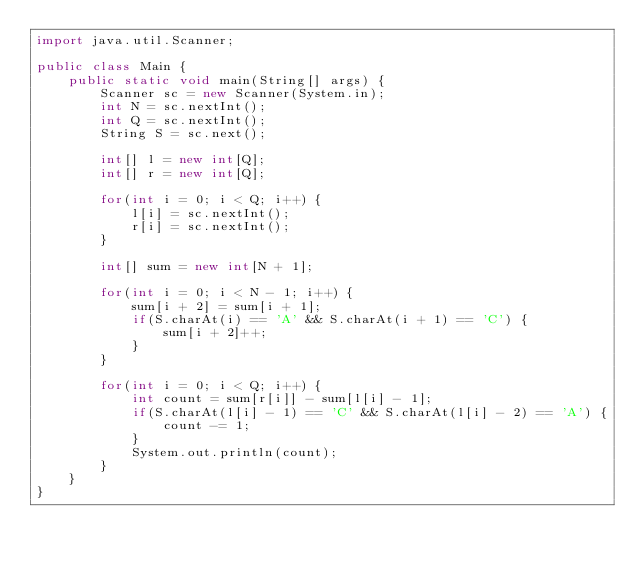<code> <loc_0><loc_0><loc_500><loc_500><_Java_>import java.util.Scanner;

public class Main {
	public static void main(String[] args) {
		Scanner sc = new Scanner(System.in);
		int N = sc.nextInt();
		int Q = sc.nextInt();
		String S = sc.next();
		
		int[] l = new int[Q];
		int[] r = new int[Q];
		
		for(int i = 0; i < Q; i++) {
			l[i] = sc.nextInt();
			r[i] = sc.nextInt();
		}
		
		int[] sum = new int[N + 1];
		
		for(int i = 0; i < N - 1; i++) {
			sum[i + 2] = sum[i + 1];
			if(S.charAt(i) == 'A' && S.charAt(i + 1) == 'C') {
				sum[i + 2]++;
			} 
		}
		
		for(int i = 0; i < Q; i++) {
			int count = sum[r[i]] - sum[l[i] - 1];
			if(S.charAt(l[i] - 1) == 'C' && S.charAt(l[i] - 2) == 'A') {
				count -= 1;
			}
			System.out.println(count);
		}
	}
}
</code> 